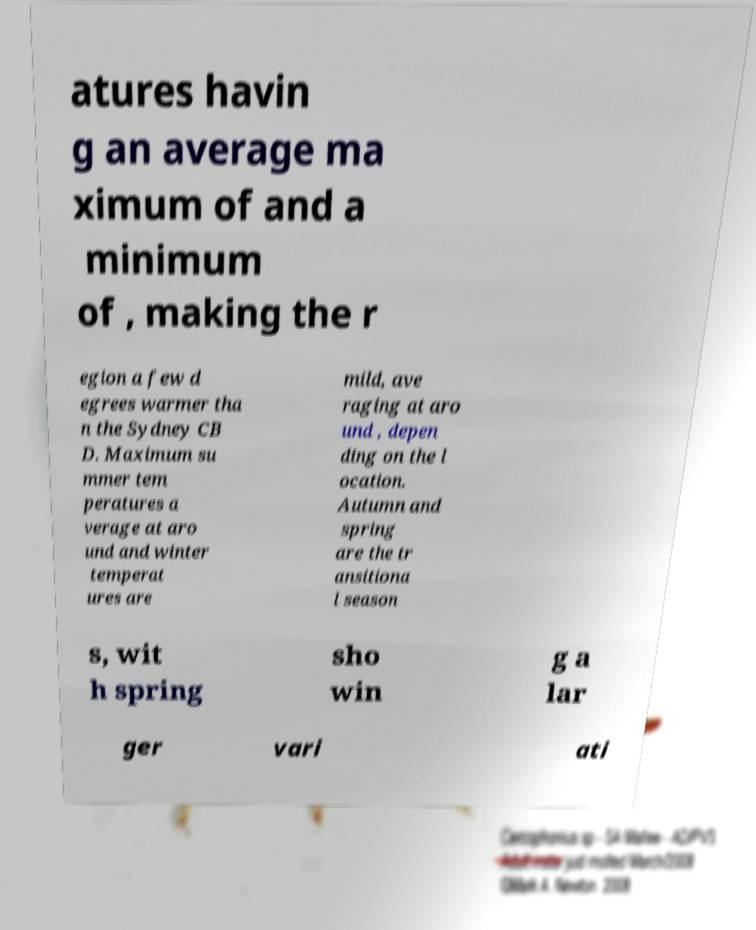Can you accurately transcribe the text from the provided image for me? atures havin g an average ma ximum of and a minimum of , making the r egion a few d egrees warmer tha n the Sydney CB D. Maximum su mmer tem peratures a verage at aro und and winter temperat ures are mild, ave raging at aro und , depen ding on the l ocation. Autumn and spring are the tr ansitiona l season s, wit h spring sho win g a lar ger vari ati 